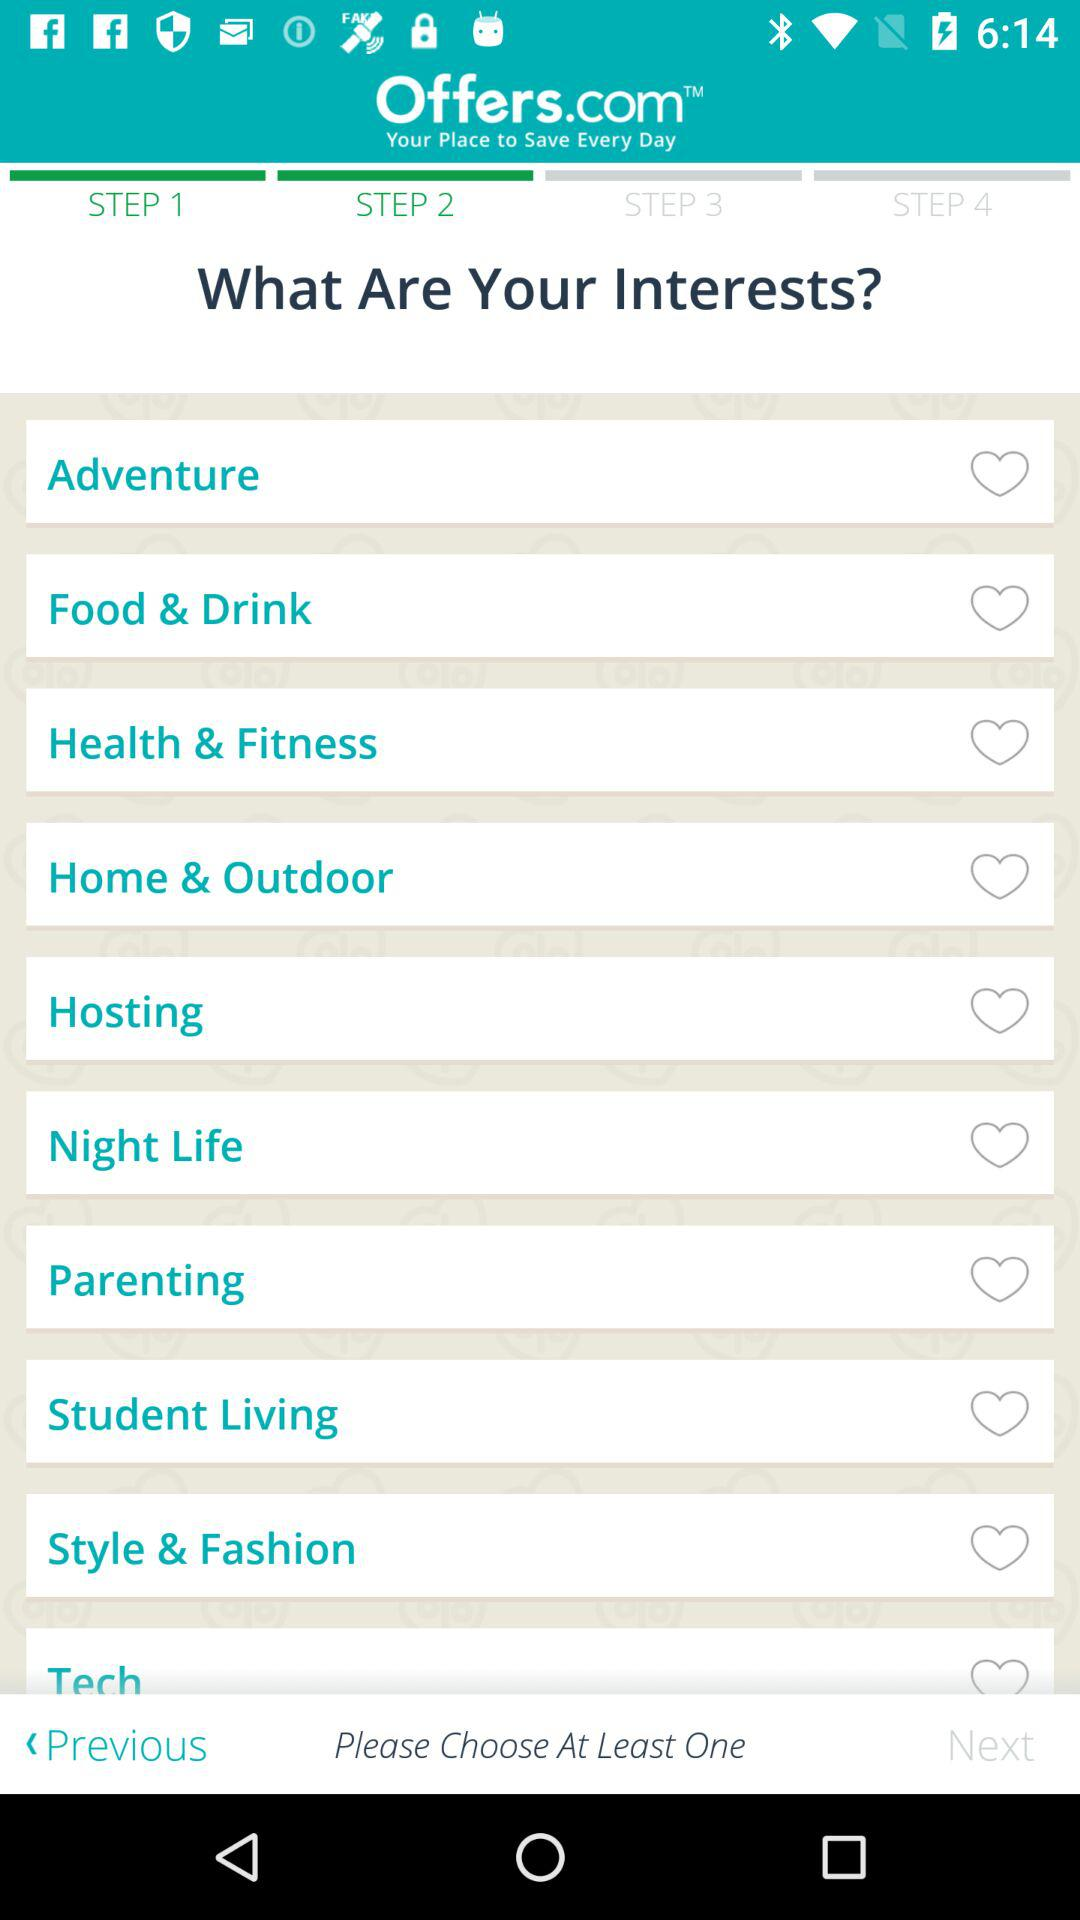What is the application name? The application name is "Offers.com". 